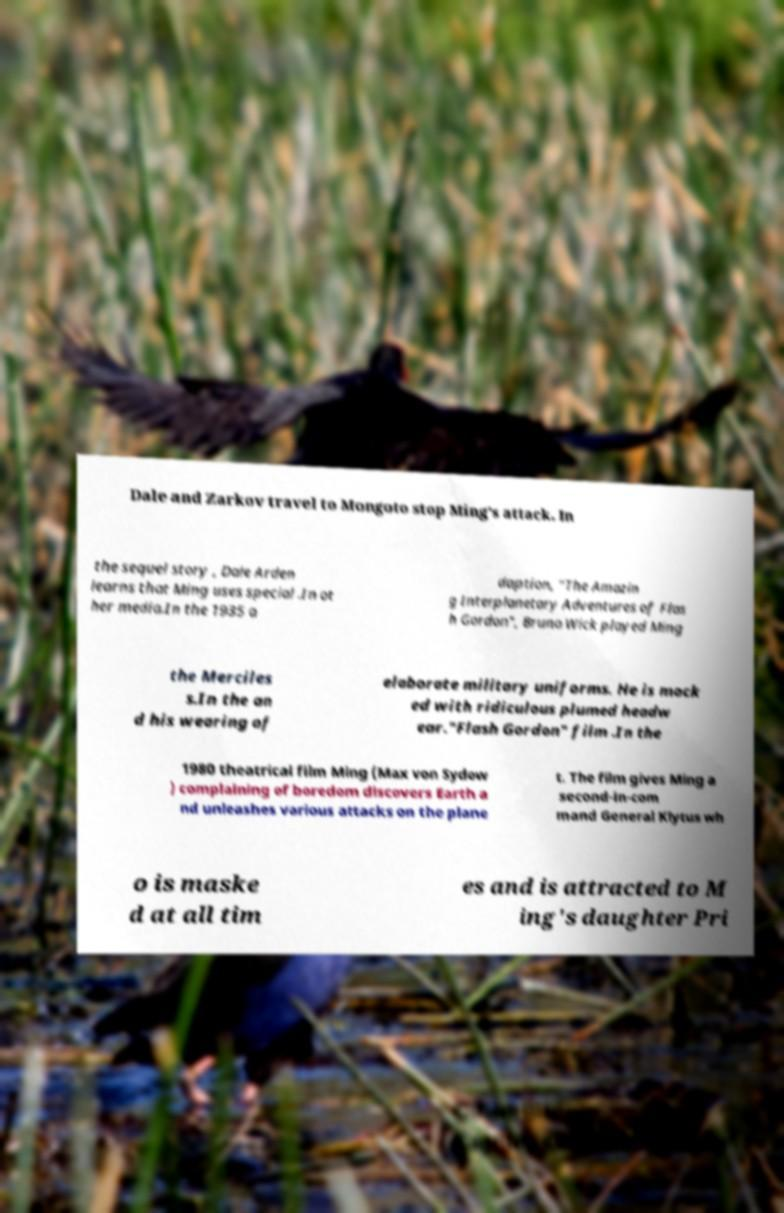Can you accurately transcribe the text from the provided image for me? Dale and Zarkov travel to Mongoto stop Ming's attack. In the sequel story , Dale Arden learns that Ming uses special .In ot her media.In the 1935 a daption, "The Amazin g Interplanetary Adventures of Flas h Gordon", Bruno Wick played Ming the Merciles s.In the an d his wearing of elaborate military uniforms. He is mock ed with ridiculous plumed headw ear."Flash Gordon" film .In the 1980 theatrical film Ming (Max von Sydow ) complaining of boredom discovers Earth a nd unleashes various attacks on the plane t. The film gives Ming a second-in-com mand General Klytus wh o is maske d at all tim es and is attracted to M ing's daughter Pri 